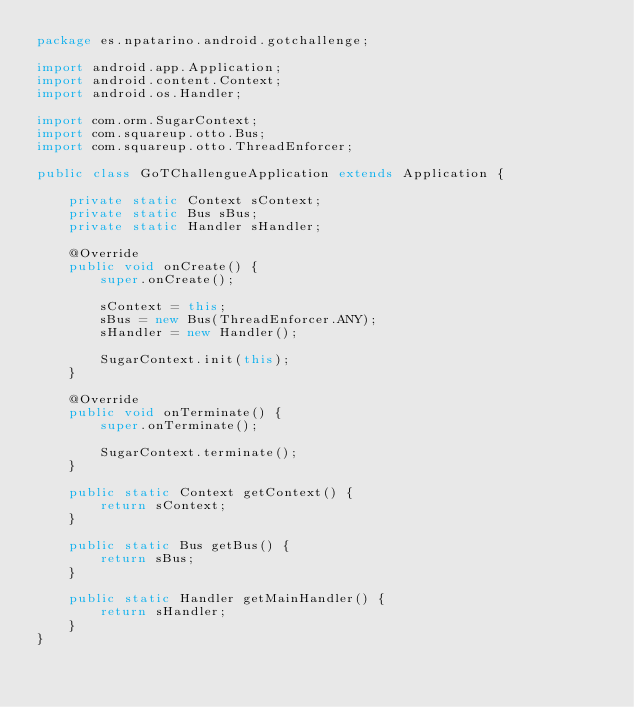Convert code to text. <code><loc_0><loc_0><loc_500><loc_500><_Java_>package es.npatarino.android.gotchallenge;

import android.app.Application;
import android.content.Context;
import android.os.Handler;

import com.orm.SugarContext;
import com.squareup.otto.Bus;
import com.squareup.otto.ThreadEnforcer;

public class GoTChallengueApplication extends Application {

    private static Context sContext;
    private static Bus sBus;
    private static Handler sHandler;

    @Override
    public void onCreate() {
        super.onCreate();

        sContext = this;
        sBus = new Bus(ThreadEnforcer.ANY);
        sHandler = new Handler();

        SugarContext.init(this);
    }

    @Override
    public void onTerminate() {
        super.onTerminate();

        SugarContext.terminate();
    }

    public static Context getContext() {
        return sContext;
    }

    public static Bus getBus() {
        return sBus;
    }

    public static Handler getMainHandler() {
        return sHandler;
    }
}
</code> 